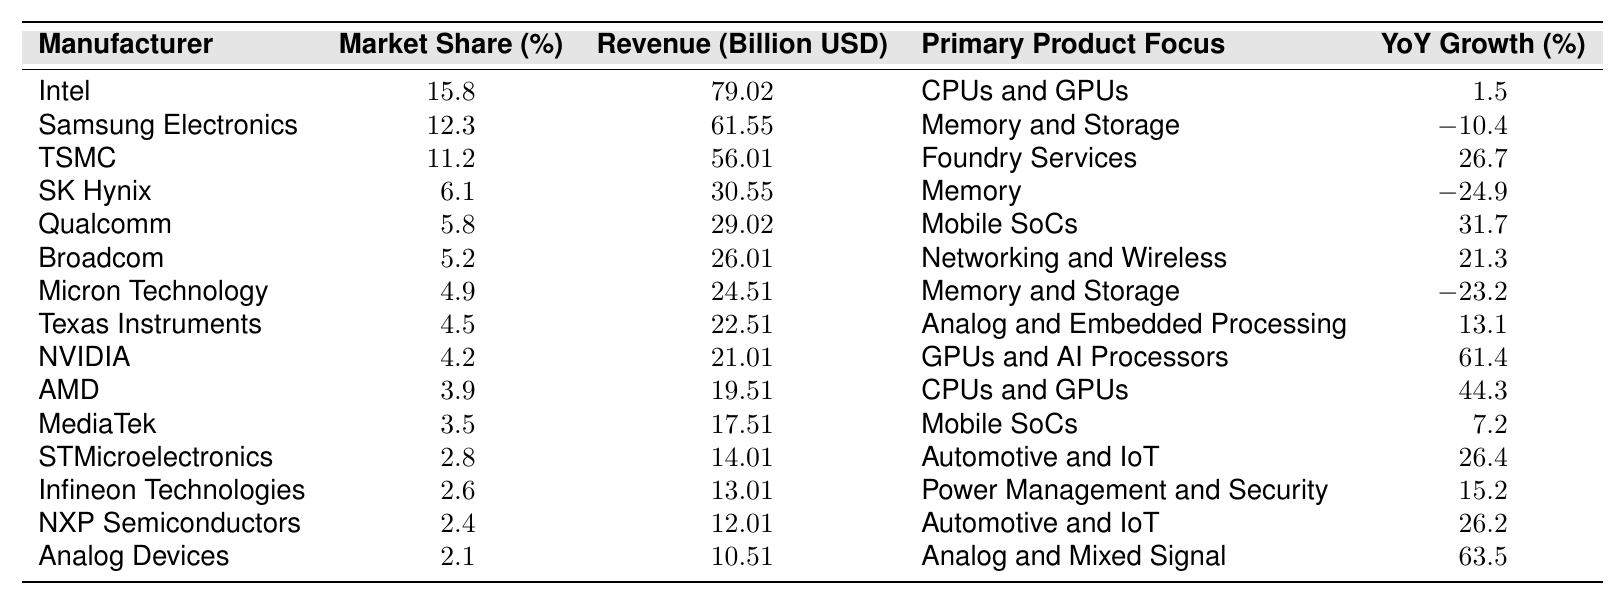What's the market share percentage of TSMC? The table indicates that TSMC has a market share percentage listed right next to its name. That value is 11.2%.
Answer: 11.2% Which manufacturer has the highest revenue? By comparing the revenue values across all manufacturers, Intel has the highest revenue with 79.02 billion USD.
Answer: Intel What is the YoY growth percentage for NVIDIA? The YoY growth percentage for NVIDIA can be found in its respective row, which shows a value of 61.4%.
Answer: 61.4% Calculate the total market share of the top three manufacturers. Add the market shares of Intel (15.8%), Samsung Electronics (12.3%), and TSMC (11.2%). The total is 15.8 + 12.3 + 11.2 = 39.3%.
Answer: 39.3% Is Qualcomm's YoY growth positive or negative? Looking at the YoY growth percentage for Qualcomm, which is 31.7%, it's evident this value is positive.
Answer: Yes Which manufacturer has the lowest market share, and what is that value? Scanning the table, Analog Devices has the lowest market share at 2.1%.
Answer: Analog Devices, 2.1% What is the difference in revenue between AMD and Broadcom? The revenue for AMD is 19.51 billion USD, while Broadcom's revenue is 26.01 billion USD. The difference is 26.01 - 19.51 = 6.50 billion USD.
Answer: 6.50 billion USD How many manufacturers have a YoY growth greater than 20%? Reviewing the YoY growth percentages, TSMC (26.7%), Qualcomm (31.7%), Broadcom (21.3%), STMicroelectronics (26.4%), NXP Semiconductors (26.2%), NVIDIA (61.4%), and AMD (44.3%) all exceed 20%. Thus, there are 7 manufacturers.
Answer: 7 Is SK Hynix's YoY growth percentage higher than that of Micron Technology? SK Hynix has a YoY growth of -24.9%, and Micron Technology has -23.2%. Since -24.9 is less than -23.2, the answer is no.
Answer: No What percentage of the total market share do the bottom five manufacturers represent? Summing the market shares of the bottom five manufacturers: Micron Technology (4.9%), Texas Instruments (4.5%), NVIDIA (4.2%), AMD (3.9%), MediaTek (3.5%). The total is 4.9 + 4.5 + 4.2 + 3.9 + 3.5 = 21.0%. The bottom five represent 21.0% of the total market share.
Answer: 21.0% 